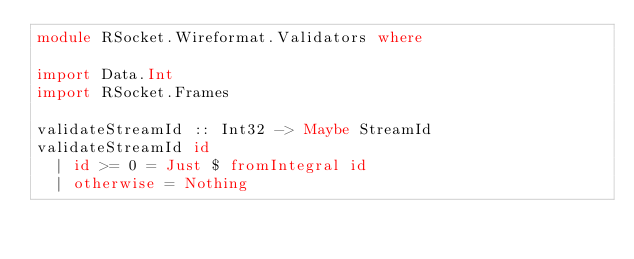Convert code to text. <code><loc_0><loc_0><loc_500><loc_500><_Haskell_>module RSocket.Wireformat.Validators where

import Data.Int
import RSocket.Frames

validateStreamId :: Int32 -> Maybe StreamId
validateStreamId id
  | id >= 0 = Just $ fromIntegral id
  | otherwise = Nothing

</code> 